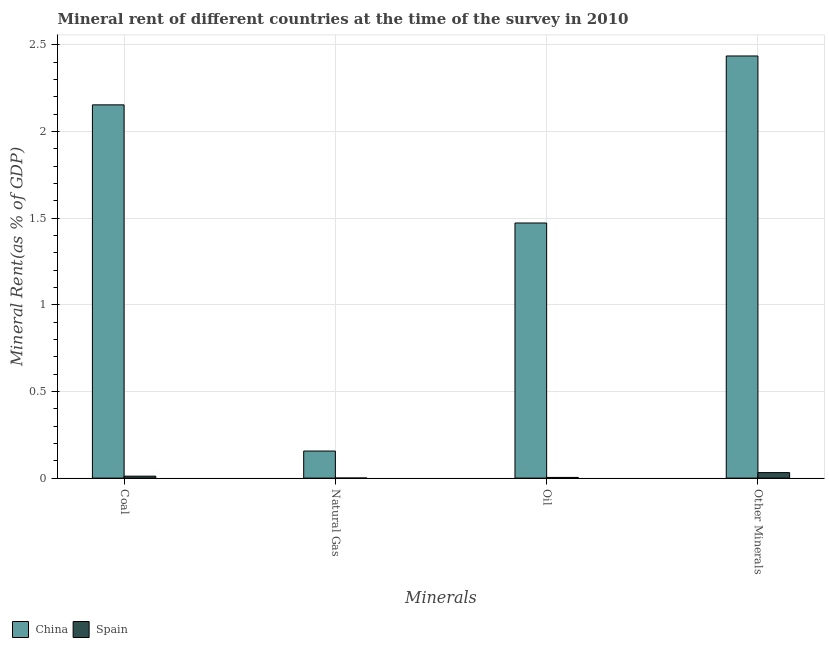How many groups of bars are there?
Ensure brevity in your answer.  4. Are the number of bars on each tick of the X-axis equal?
Make the answer very short. Yes. How many bars are there on the 3rd tick from the right?
Offer a very short reply. 2. What is the label of the 1st group of bars from the left?
Your answer should be compact. Coal. What is the oil rent in Spain?
Give a very brief answer. 0. Across all countries, what is the maximum  rent of other minerals?
Make the answer very short. 2.44. Across all countries, what is the minimum oil rent?
Provide a short and direct response. 0. In which country was the coal rent maximum?
Give a very brief answer. China. What is the total coal rent in the graph?
Offer a terse response. 2.16. What is the difference between the oil rent in Spain and that in China?
Your answer should be compact. -1.47. What is the difference between the coal rent in China and the  rent of other minerals in Spain?
Give a very brief answer. 2.12. What is the average coal rent per country?
Ensure brevity in your answer.  1.08. What is the difference between the coal rent and oil rent in Spain?
Provide a short and direct response. 0.01. In how many countries, is the coal rent greater than 0.30000000000000004 %?
Offer a terse response. 1. What is the ratio of the  rent of other minerals in China to that in Spain?
Your response must be concise. 76.67. What is the difference between the highest and the second highest oil rent?
Provide a short and direct response. 1.47. What is the difference between the highest and the lowest oil rent?
Provide a succinct answer. 1.47. Is the sum of the oil rent in Spain and China greater than the maximum natural gas rent across all countries?
Provide a succinct answer. Yes. Is it the case that in every country, the sum of the  rent of other minerals and natural gas rent is greater than the sum of oil rent and coal rent?
Your response must be concise. No. Is it the case that in every country, the sum of the coal rent and natural gas rent is greater than the oil rent?
Your response must be concise. Yes. Are all the bars in the graph horizontal?
Provide a short and direct response. No. How many countries are there in the graph?
Give a very brief answer. 2. Does the graph contain grids?
Keep it short and to the point. Yes. How are the legend labels stacked?
Provide a succinct answer. Horizontal. What is the title of the graph?
Give a very brief answer. Mineral rent of different countries at the time of the survey in 2010. Does "Mauritania" appear as one of the legend labels in the graph?
Make the answer very short. No. What is the label or title of the X-axis?
Make the answer very short. Minerals. What is the label or title of the Y-axis?
Keep it short and to the point. Mineral Rent(as % of GDP). What is the Mineral Rent(as % of GDP) of China in Coal?
Keep it short and to the point. 2.15. What is the Mineral Rent(as % of GDP) of Spain in Coal?
Keep it short and to the point. 0.01. What is the Mineral Rent(as % of GDP) in China in Natural Gas?
Keep it short and to the point. 0.16. What is the Mineral Rent(as % of GDP) of Spain in Natural Gas?
Your response must be concise. 0. What is the Mineral Rent(as % of GDP) of China in Oil?
Provide a short and direct response. 1.47. What is the Mineral Rent(as % of GDP) of Spain in Oil?
Your response must be concise. 0. What is the Mineral Rent(as % of GDP) of China in Other Minerals?
Offer a terse response. 2.44. What is the Mineral Rent(as % of GDP) in Spain in Other Minerals?
Your answer should be compact. 0.03. Across all Minerals, what is the maximum Mineral Rent(as % of GDP) of China?
Provide a succinct answer. 2.44. Across all Minerals, what is the maximum Mineral Rent(as % of GDP) of Spain?
Give a very brief answer. 0.03. Across all Minerals, what is the minimum Mineral Rent(as % of GDP) in China?
Make the answer very short. 0.16. Across all Minerals, what is the minimum Mineral Rent(as % of GDP) in Spain?
Your answer should be compact. 0. What is the total Mineral Rent(as % of GDP) in China in the graph?
Provide a succinct answer. 6.22. What is the total Mineral Rent(as % of GDP) of Spain in the graph?
Ensure brevity in your answer.  0.05. What is the difference between the Mineral Rent(as % of GDP) in China in Coal and that in Natural Gas?
Your response must be concise. 2. What is the difference between the Mineral Rent(as % of GDP) in Spain in Coal and that in Natural Gas?
Provide a short and direct response. 0.01. What is the difference between the Mineral Rent(as % of GDP) in China in Coal and that in Oil?
Ensure brevity in your answer.  0.68. What is the difference between the Mineral Rent(as % of GDP) in Spain in Coal and that in Oil?
Provide a succinct answer. 0.01. What is the difference between the Mineral Rent(as % of GDP) in China in Coal and that in Other Minerals?
Offer a very short reply. -0.28. What is the difference between the Mineral Rent(as % of GDP) of Spain in Coal and that in Other Minerals?
Make the answer very short. -0.02. What is the difference between the Mineral Rent(as % of GDP) in China in Natural Gas and that in Oil?
Keep it short and to the point. -1.32. What is the difference between the Mineral Rent(as % of GDP) in Spain in Natural Gas and that in Oil?
Offer a very short reply. -0. What is the difference between the Mineral Rent(as % of GDP) of China in Natural Gas and that in Other Minerals?
Offer a terse response. -2.28. What is the difference between the Mineral Rent(as % of GDP) in Spain in Natural Gas and that in Other Minerals?
Provide a short and direct response. -0.03. What is the difference between the Mineral Rent(as % of GDP) in China in Oil and that in Other Minerals?
Provide a succinct answer. -0.96. What is the difference between the Mineral Rent(as % of GDP) in Spain in Oil and that in Other Minerals?
Make the answer very short. -0.03. What is the difference between the Mineral Rent(as % of GDP) in China in Coal and the Mineral Rent(as % of GDP) in Spain in Natural Gas?
Provide a short and direct response. 2.15. What is the difference between the Mineral Rent(as % of GDP) of China in Coal and the Mineral Rent(as % of GDP) of Spain in Oil?
Provide a succinct answer. 2.15. What is the difference between the Mineral Rent(as % of GDP) in China in Coal and the Mineral Rent(as % of GDP) in Spain in Other Minerals?
Provide a succinct answer. 2.12. What is the difference between the Mineral Rent(as % of GDP) in China in Natural Gas and the Mineral Rent(as % of GDP) in Spain in Oil?
Offer a terse response. 0.15. What is the difference between the Mineral Rent(as % of GDP) in China in Natural Gas and the Mineral Rent(as % of GDP) in Spain in Other Minerals?
Ensure brevity in your answer.  0.12. What is the difference between the Mineral Rent(as % of GDP) of China in Oil and the Mineral Rent(as % of GDP) of Spain in Other Minerals?
Offer a very short reply. 1.44. What is the average Mineral Rent(as % of GDP) in China per Minerals?
Provide a short and direct response. 1.55. What is the average Mineral Rent(as % of GDP) in Spain per Minerals?
Make the answer very short. 0.01. What is the difference between the Mineral Rent(as % of GDP) of China and Mineral Rent(as % of GDP) of Spain in Coal?
Provide a succinct answer. 2.14. What is the difference between the Mineral Rent(as % of GDP) in China and Mineral Rent(as % of GDP) in Spain in Natural Gas?
Your answer should be compact. 0.16. What is the difference between the Mineral Rent(as % of GDP) in China and Mineral Rent(as % of GDP) in Spain in Oil?
Provide a succinct answer. 1.47. What is the difference between the Mineral Rent(as % of GDP) of China and Mineral Rent(as % of GDP) of Spain in Other Minerals?
Provide a succinct answer. 2.4. What is the ratio of the Mineral Rent(as % of GDP) of China in Coal to that in Natural Gas?
Give a very brief answer. 13.78. What is the ratio of the Mineral Rent(as % of GDP) of Spain in Coal to that in Natural Gas?
Your answer should be compact. 24.78. What is the ratio of the Mineral Rent(as % of GDP) in China in Coal to that in Oil?
Your answer should be compact. 1.46. What is the ratio of the Mineral Rent(as % of GDP) of Spain in Coal to that in Oil?
Provide a short and direct response. 2.84. What is the ratio of the Mineral Rent(as % of GDP) in China in Coal to that in Other Minerals?
Offer a very short reply. 0.88. What is the ratio of the Mineral Rent(as % of GDP) in Spain in Coal to that in Other Minerals?
Your response must be concise. 0.35. What is the ratio of the Mineral Rent(as % of GDP) in China in Natural Gas to that in Oil?
Your answer should be compact. 0.11. What is the ratio of the Mineral Rent(as % of GDP) in Spain in Natural Gas to that in Oil?
Offer a terse response. 0.11. What is the ratio of the Mineral Rent(as % of GDP) of China in Natural Gas to that in Other Minerals?
Your response must be concise. 0.06. What is the ratio of the Mineral Rent(as % of GDP) in Spain in Natural Gas to that in Other Minerals?
Your answer should be very brief. 0.01. What is the ratio of the Mineral Rent(as % of GDP) of China in Oil to that in Other Minerals?
Offer a terse response. 0.6. What is the ratio of the Mineral Rent(as % of GDP) of Spain in Oil to that in Other Minerals?
Offer a very short reply. 0.12. What is the difference between the highest and the second highest Mineral Rent(as % of GDP) of China?
Offer a terse response. 0.28. What is the difference between the highest and the second highest Mineral Rent(as % of GDP) of Spain?
Provide a succinct answer. 0.02. What is the difference between the highest and the lowest Mineral Rent(as % of GDP) in China?
Keep it short and to the point. 2.28. What is the difference between the highest and the lowest Mineral Rent(as % of GDP) in Spain?
Your answer should be very brief. 0.03. 